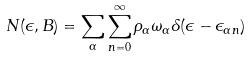<formula> <loc_0><loc_0><loc_500><loc_500>N ( \epsilon , B ) = \sum _ { \alpha } \sum _ { n = 0 } ^ { \infty } \rho _ { \alpha } \omega _ { \alpha } \delta ( \epsilon - \epsilon _ { \alpha n } )</formula> 